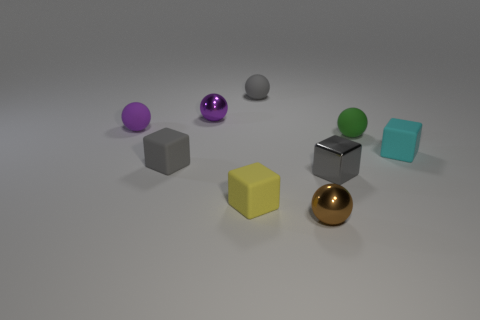Subtract 2 balls. How many balls are left? 3 Subtract all green spheres. How many spheres are left? 4 Subtract all small metal cubes. How many cubes are left? 3 Subtract all red balls. Subtract all cyan cylinders. How many balls are left? 5 Subtract all cubes. How many objects are left? 5 Add 8 tiny brown spheres. How many tiny brown spheres exist? 9 Subtract 1 cyan cubes. How many objects are left? 8 Subtract all tiny shiny cubes. Subtract all purple metallic balls. How many objects are left? 7 Add 5 tiny brown metal spheres. How many tiny brown metal spheres are left? 6 